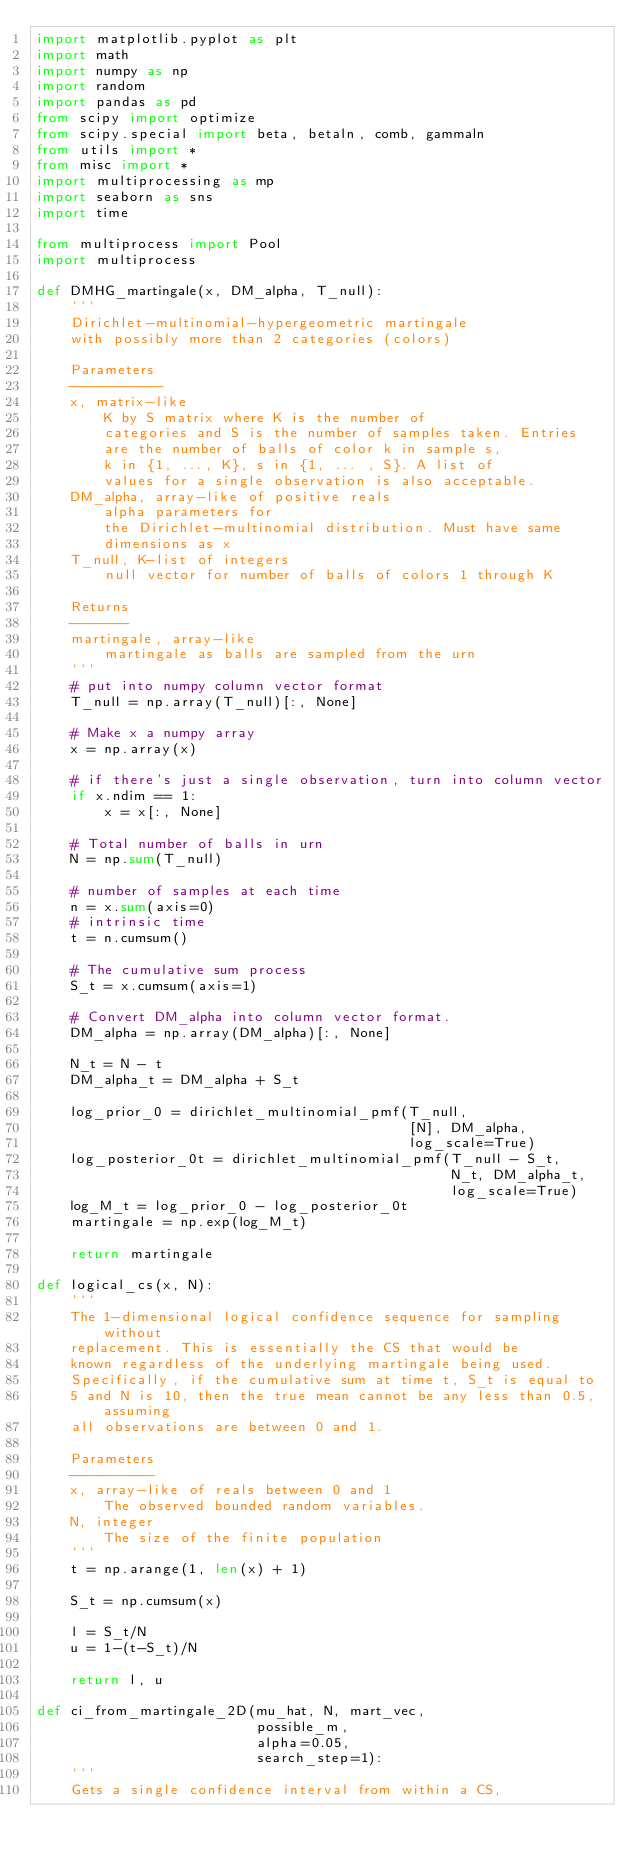<code> <loc_0><loc_0><loc_500><loc_500><_Python_>import matplotlib.pyplot as plt
import math
import numpy as np
import random
import pandas as pd
from scipy import optimize
from scipy.special import beta, betaln, comb, gammaln
from utils import *
from misc import *
import multiprocessing as mp
import seaborn as sns
import time

from multiprocess import Pool
import multiprocess

def DMHG_martingale(x, DM_alpha, T_null):
    '''
    Dirichlet-multinomial-hypergeometric martingale
    with possibly more than 2 categories (colors)

    Parameters
    -----------
    x, matrix-like
        K by S matrix where K is the number of
        categories and S is the number of samples taken. Entries
        are the number of balls of color k in sample s,
        k in {1, ..., K}, s in {1, ... , S}. A list of
        values for a single observation is also acceptable.
    DM_alpha, array-like of positive reals
        alpha parameters for
        the Dirichlet-multinomial distribution. Must have same
        dimensions as x
    T_null, K-list of integers
        null vector for number of balls of colors 1 through K

    Returns
    -------
    martingale, array-like
        martingale as balls are sampled from the urn
    '''
    # put into numpy column vector format
    T_null = np.array(T_null)[:, None]

    # Make x a numpy array
    x = np.array(x)

    # if there's just a single observation, turn into column vector
    if x.ndim == 1:
        x = x[:, None]

    # Total number of balls in urn
    N = np.sum(T_null)

    # number of samples at each time
    n = x.sum(axis=0)
    # intrinsic time
    t = n.cumsum()

    # The cumulative sum process
    S_t = x.cumsum(axis=1)

    # Convert DM_alpha into column vector format.
    DM_alpha = np.array(DM_alpha)[:, None]

    N_t = N - t
    DM_alpha_t = DM_alpha + S_t

    log_prior_0 = dirichlet_multinomial_pmf(T_null,
                                            [N], DM_alpha,
                                            log_scale=True)
    log_posterior_0t = dirichlet_multinomial_pmf(T_null - S_t,
                                                 N_t, DM_alpha_t,
                                                 log_scale=True)
    log_M_t = log_prior_0 - log_posterior_0t
    martingale = np.exp(log_M_t)

    return martingale

def logical_cs(x, N):
    '''
    The 1-dimensional logical confidence sequence for sampling without
    replacement. This is essentially the CS that would be 
    known regardless of the underlying martingale being used.
    Specifically, if the cumulative sum at time t, S_t is equal to
    5 and N is 10, then the true mean cannot be any less than 0.5, assuming
    all observations are between 0 and 1.

    Parameters
    ----------
    x, array-like of reals between 0 and 1
        The observed bounded random variables.
    N, integer
        The size of the finite population
    '''
    t = np.arange(1, len(x) + 1)

    S_t = np.cumsum(x)

    l = S_t/N
    u = 1-(t-S_t)/N

    return l, u 

def ci_from_martingale_2D(mu_hat, N, mart_vec,
                          possible_m,
                          alpha=0.05,
                          search_step=1):
    '''
    Gets a single confidence interval from within a CS,</code> 